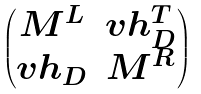<formula> <loc_0><loc_0><loc_500><loc_500>\begin{pmatrix} M ^ { L } & v h _ { D } ^ { T } \\ v h _ { D } & M ^ { R } \end{pmatrix}</formula> 